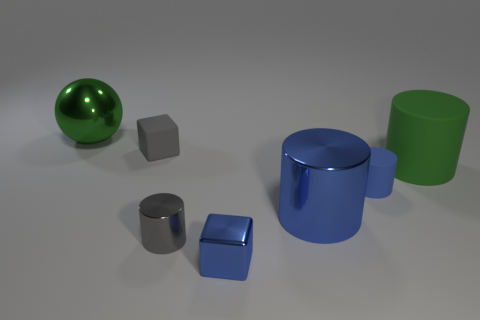There is a large metallic object that is to the right of the green object that is to the left of the small gray cylinder; what is its color?
Your answer should be compact. Blue. Are there fewer matte cylinders that are in front of the metal block than shiny cylinders that are behind the large green matte cylinder?
Provide a succinct answer. No. Do the blue shiny cylinder and the gray cylinder have the same size?
Give a very brief answer. No. What shape is the big thing that is both to the left of the large green rubber object and to the right of the small rubber cube?
Offer a very short reply. Cylinder. How many small cylinders have the same material as the gray block?
Ensure brevity in your answer.  1. There is a green object to the right of the green metallic object; how many blue things are on the right side of it?
Offer a very short reply. 0. What is the shape of the small rubber thing that is on the left side of the metal cylinder on the left side of the big metal object that is to the right of the big shiny ball?
Give a very brief answer. Cube. There is a cylinder that is the same color as the rubber cube; what is its size?
Provide a short and direct response. Small. What number of things are matte cubes or big matte cylinders?
Provide a succinct answer. 2. What color is the metal object that is the same size as the blue metallic cube?
Keep it short and to the point. Gray. 